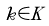<formula> <loc_0><loc_0><loc_500><loc_500>\tilde { k } \in \tilde { K }</formula> 